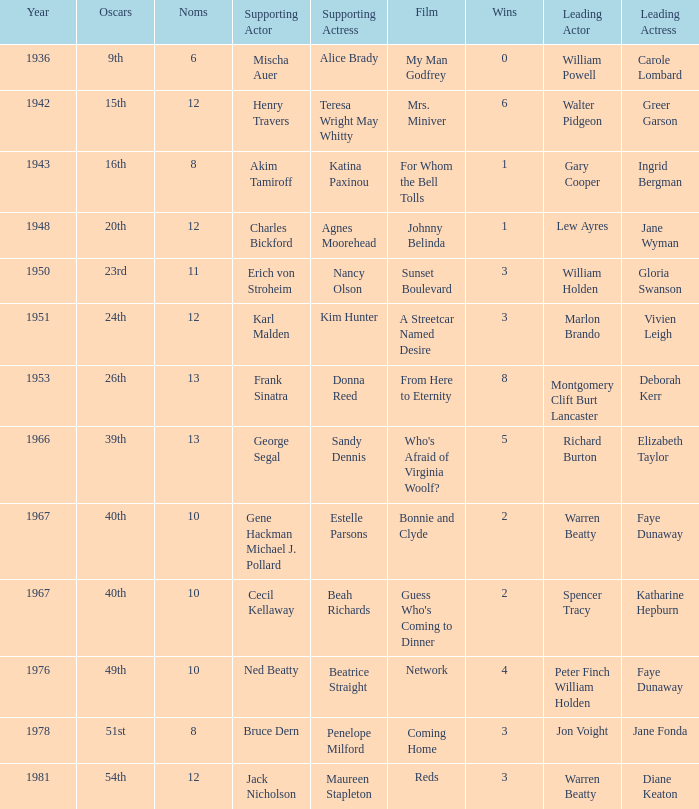Who was the leading actress in a film with Warren Beatty as the leading actor and also at the 40th Oscars? Faye Dunaway. 